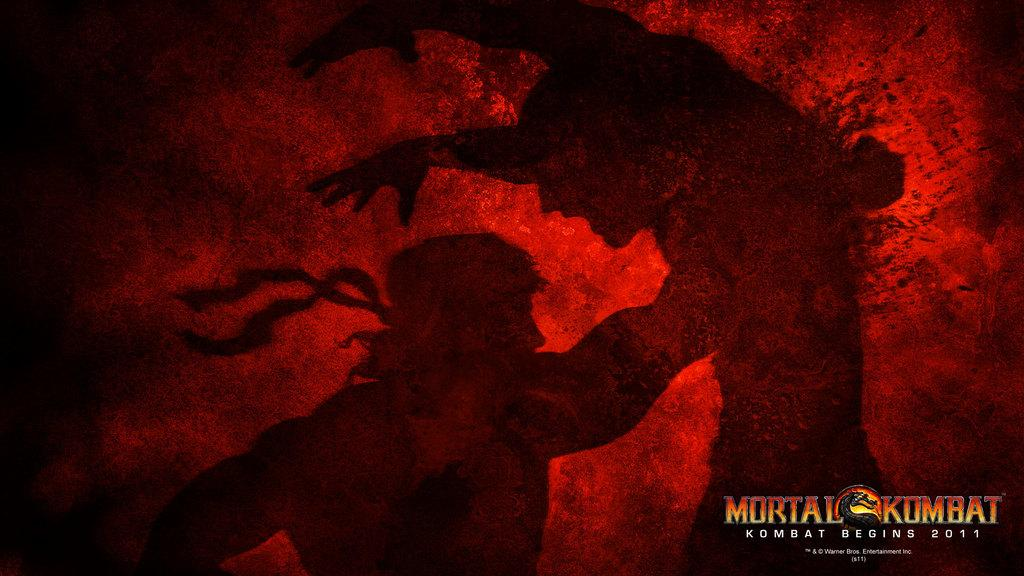<image>
Provide a brief description of the given image. A screenshot of a game is labelled as being from Mortal Kombat, which begins in 2011. 